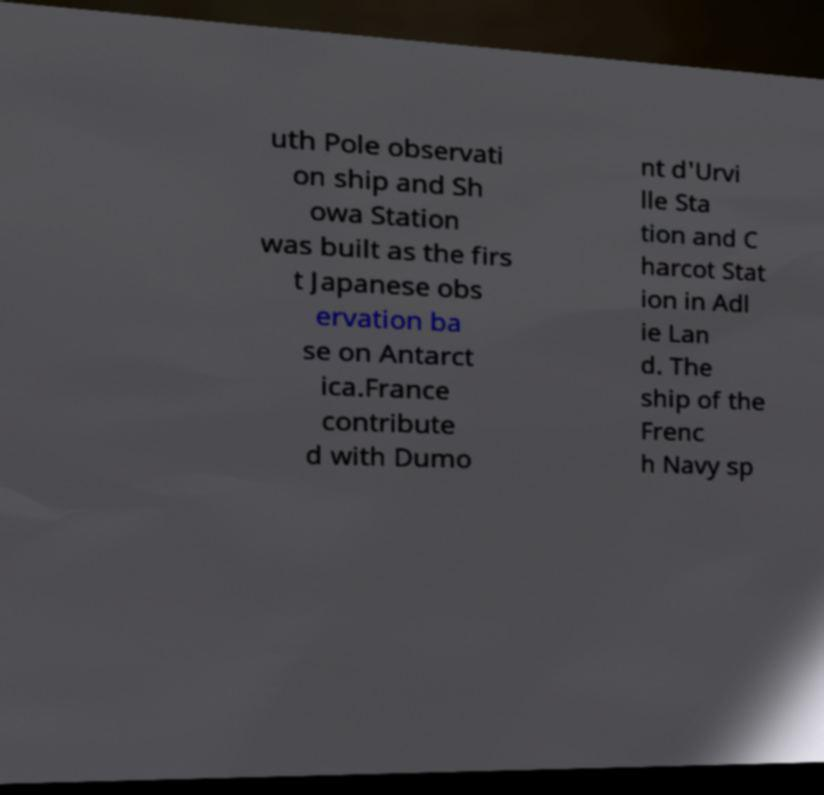What messages or text are displayed in this image? I need them in a readable, typed format. uth Pole observati on ship and Sh owa Station was built as the firs t Japanese obs ervation ba se on Antarct ica.France contribute d with Dumo nt d'Urvi lle Sta tion and C harcot Stat ion in Adl ie Lan d. The ship of the Frenc h Navy sp 